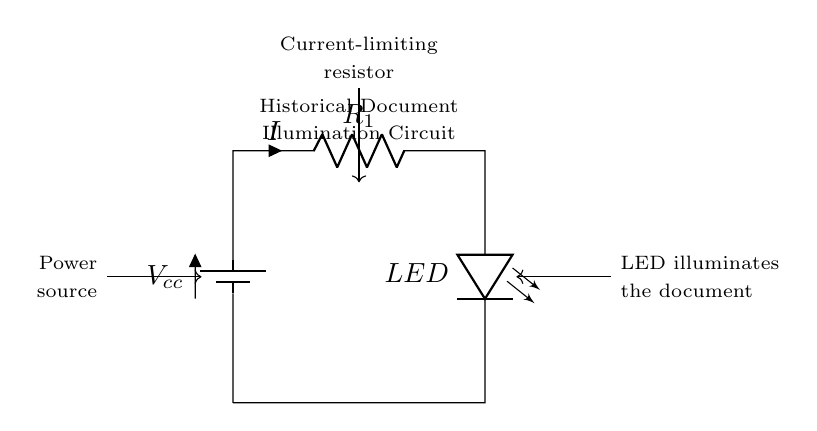What is the power source in this circuit? The power source in the circuit is the battery, indicated by the label "Vcc." This supplies the necessary voltage for the circuit to operate.
Answer: Battery What is the purpose of the resistor in this LED circuit? The purpose of the resistor, labeled as "R1," is to limit the current flowing through the LED. This protects the LED from excessive current which could damage it.
Answer: Limit current What component is used to illuminate the document? The component used to illuminate the document is the LED, which is labeled in the circuit and is responsible for producing light when current flows through it.
Answer: LED What is the direction of current flow in this circuit? The current flows from the positive terminal of the battery, through the resistor, and then through the LED before returning to the negative terminal of the battery. This is indicated by the arrow labeled "I."
Answer: From battery to LED How does the resistor value affect LED brightness? The resistor value affects the LED brightness by controlling the amount of current that flows through the LED; a lower resistor value allows more current and increases brightness, while a higher value reduces current and dimness.
Answer: Controls brightness What would happen if the LED is connected directly across the battery? If the LED is connected directly across the battery without the resistor, the excessive current could lead to immediate damage or failure of the LED due to overheating.
Answer: LED damage What is the overall function of this circuit? The overall function of this circuit is to provide a controlled current to the LED, allowing it to illuminate historical documents safely without damaging the light source.
Answer: Illumination circuit 